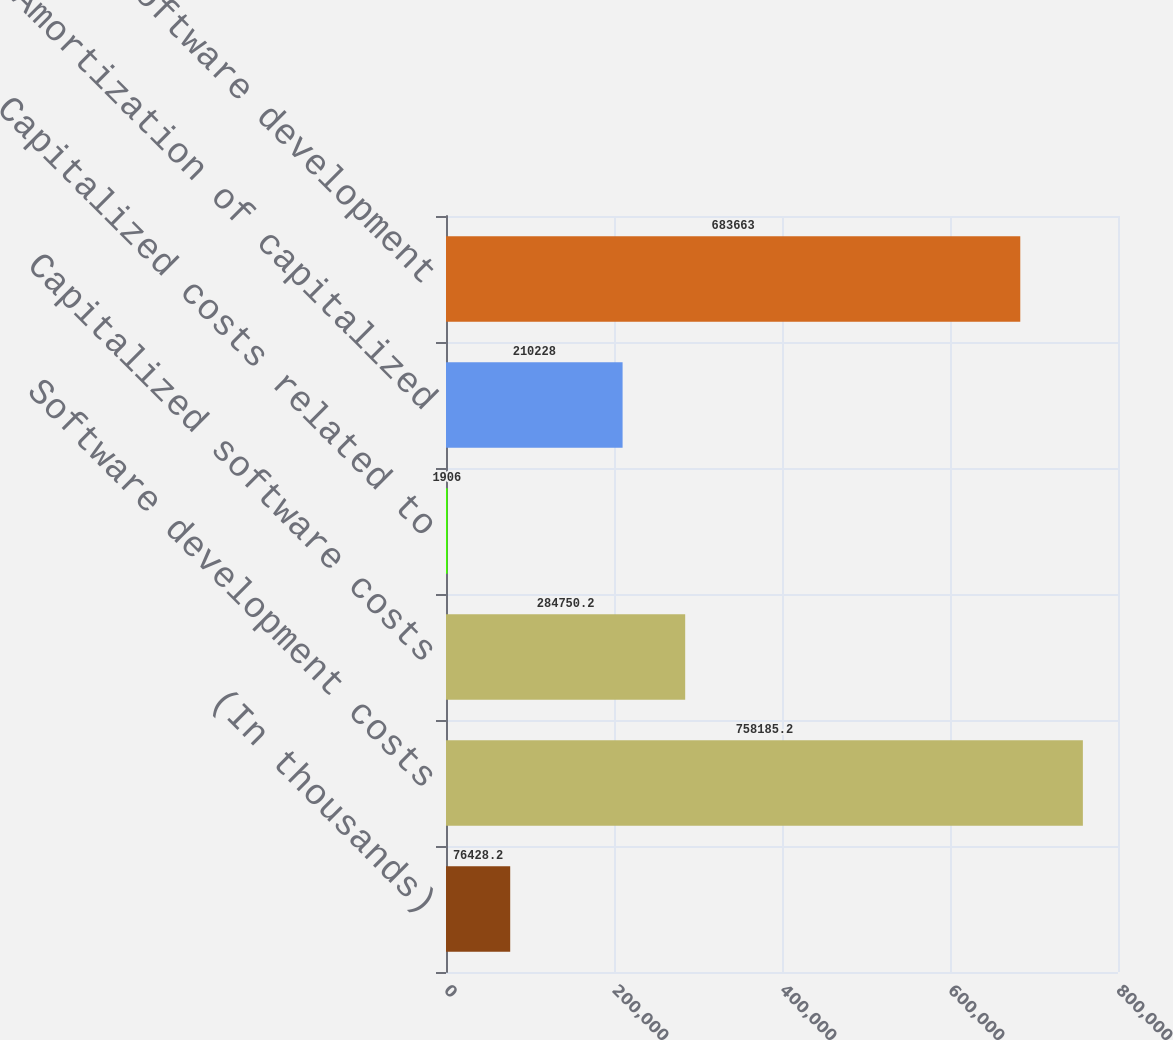Convert chart to OTSL. <chart><loc_0><loc_0><loc_500><loc_500><bar_chart><fcel>(In thousands)<fcel>Software development costs<fcel>Capitalized software costs<fcel>Capitalized costs related to<fcel>Amortization of capitalized<fcel>Total software development<nl><fcel>76428.2<fcel>758185<fcel>284750<fcel>1906<fcel>210228<fcel>683663<nl></chart> 